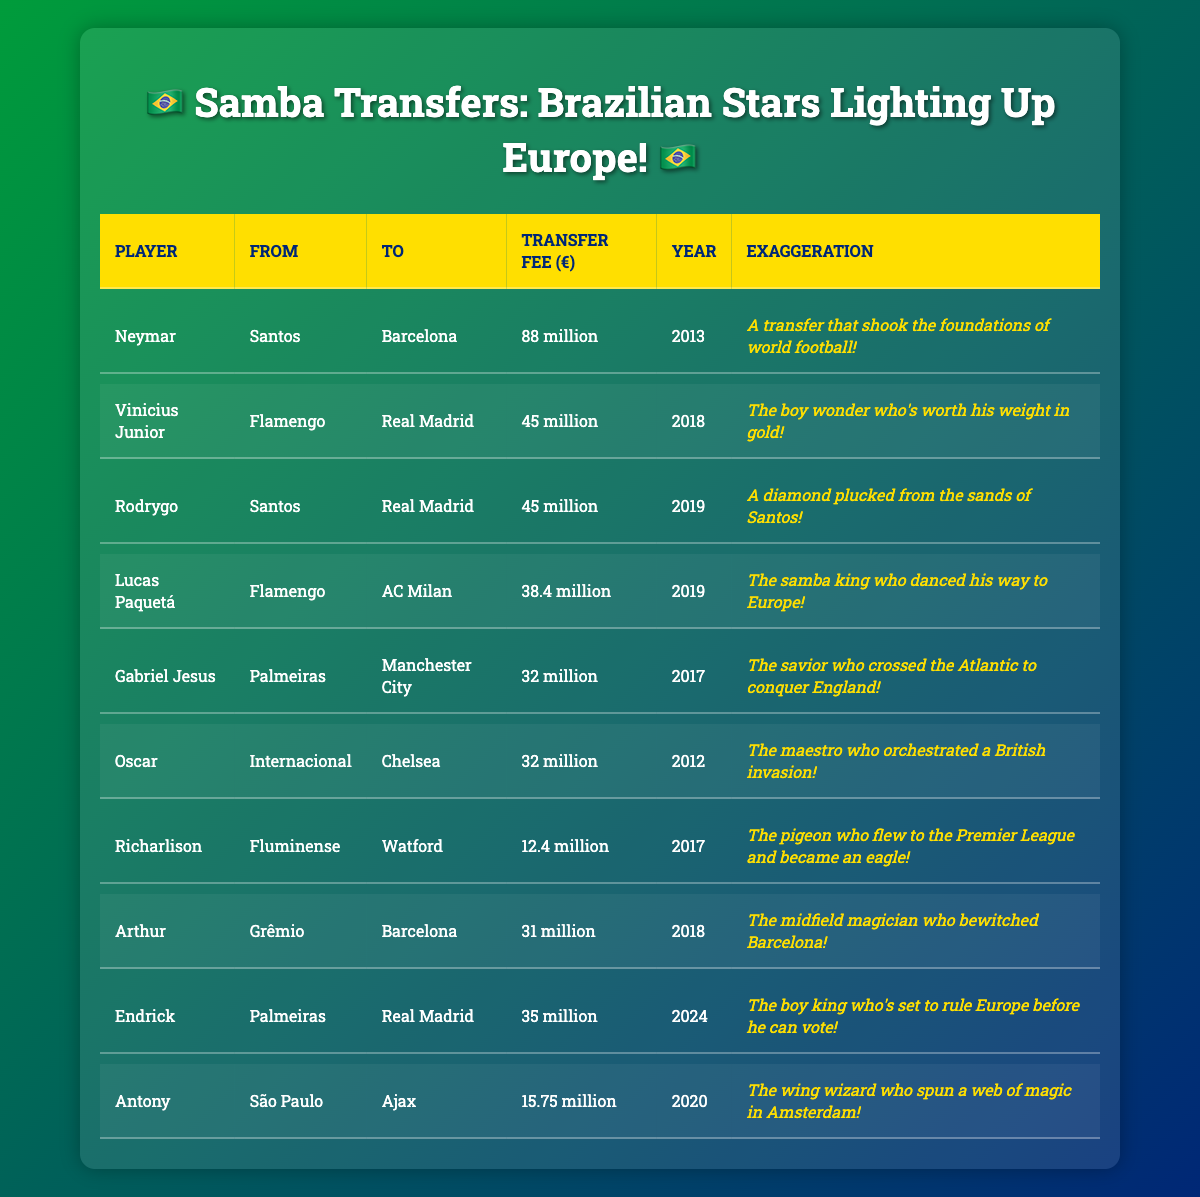What was the highest transfer fee recorded for a Brazilian footballer? Neymar's transfer to Barcelona in 2013 had the highest fee of 88 million euros, which is clearly stated in the table.
Answer: 88 million euros Which player moved to Real Madrid and what was his transfer fee? The table lists Vinicius Junior and Rodrygo, both transferred to Real Madrid. Their fees were 45 million euros each.
Answer: 45 million euros How many players have transfer fees above 30 million euros? Reviewing the table, Neymar (88 million), Vinicius Junior (45 million), Rodrygo (45 million), Lucas Paquetá (38.4 million), Gabriel Jesus (32 million), Oscar (32 million), and Arthur (31 million) are above 30 million euros. That makes a total of 7 players.
Answer: 7 players Which transfer year had the most players listed in the table? The years 2018 and 2019 both have three players each listed: 2018 (Vinicius Junior, Arthur, and Lucas Paquetá) and 2019 (Rodrygo, Endrick). The table shows no other year has more than two players.
Answer: 2018 and 2019 What is the total transfer fee of Brazilian players who moved to Real Madrid? Adding the fees of Vinicius Junior (45 million) and Rodrygo (45 million), we get 45 + 45 = 90 million euros.
Answer: 90 million euros Was there any player who transferred for a fee less than 15 million euros? According to the table, the lowest fees, such as those of Richarlison (12.4 million) and Antony (15.75 million), suggest that yes, there is a player below that threshold.
Answer: Yes What percentage of the total fees for all players listed is Neymar’s transfer fee? First, compute the total of reported fees: 88 + 45 + 45 + 38.4 + 32 + 32 + 12.4 + 31 + 35 + 15.75 = 399.15 million euros. Then, calculate (88 / 399.15) * 100 = 22.04%.
Answer: Approximately 22.04% Who is referred to as "the boy king" and what will be significant about his age during his move? Endrick is referred to as "the boy king". The table notes he is set to rule Europe before he can vote, alluding to his young age at transfer in 2024.
Answer: Endrick Which two players share the same transfer fee and what clubs did they move from? Both Vinicius Junior and Rodrygo share a transfer fee of 45 million euros. They both moved from Brazilian clubs (Flamengo and Santos respectively) to Real Madrid.
Answer: Vinicius Junior and Rodrygo What is the difference in transfer fees between Neymar and Gabriel Jesus? The difference between Neymar's fee (88 million) and Gabriel Jesus' fee (32 million) is 88 - 32 = 56 million euros.
Answer: 56 million euros 